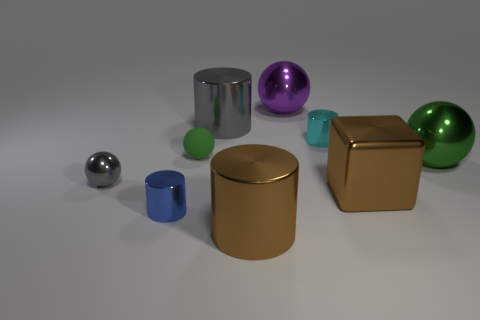Subtract 1 balls. How many balls are left? 3 Add 1 green matte spheres. How many objects exist? 10 Subtract all cylinders. How many objects are left? 5 Subtract 0 yellow cylinders. How many objects are left? 9 Subtract all brown blocks. Subtract all large purple balls. How many objects are left? 7 Add 7 small blue metal cylinders. How many small blue metal cylinders are left? 8 Add 8 big purple shiny spheres. How many big purple shiny spheres exist? 9 